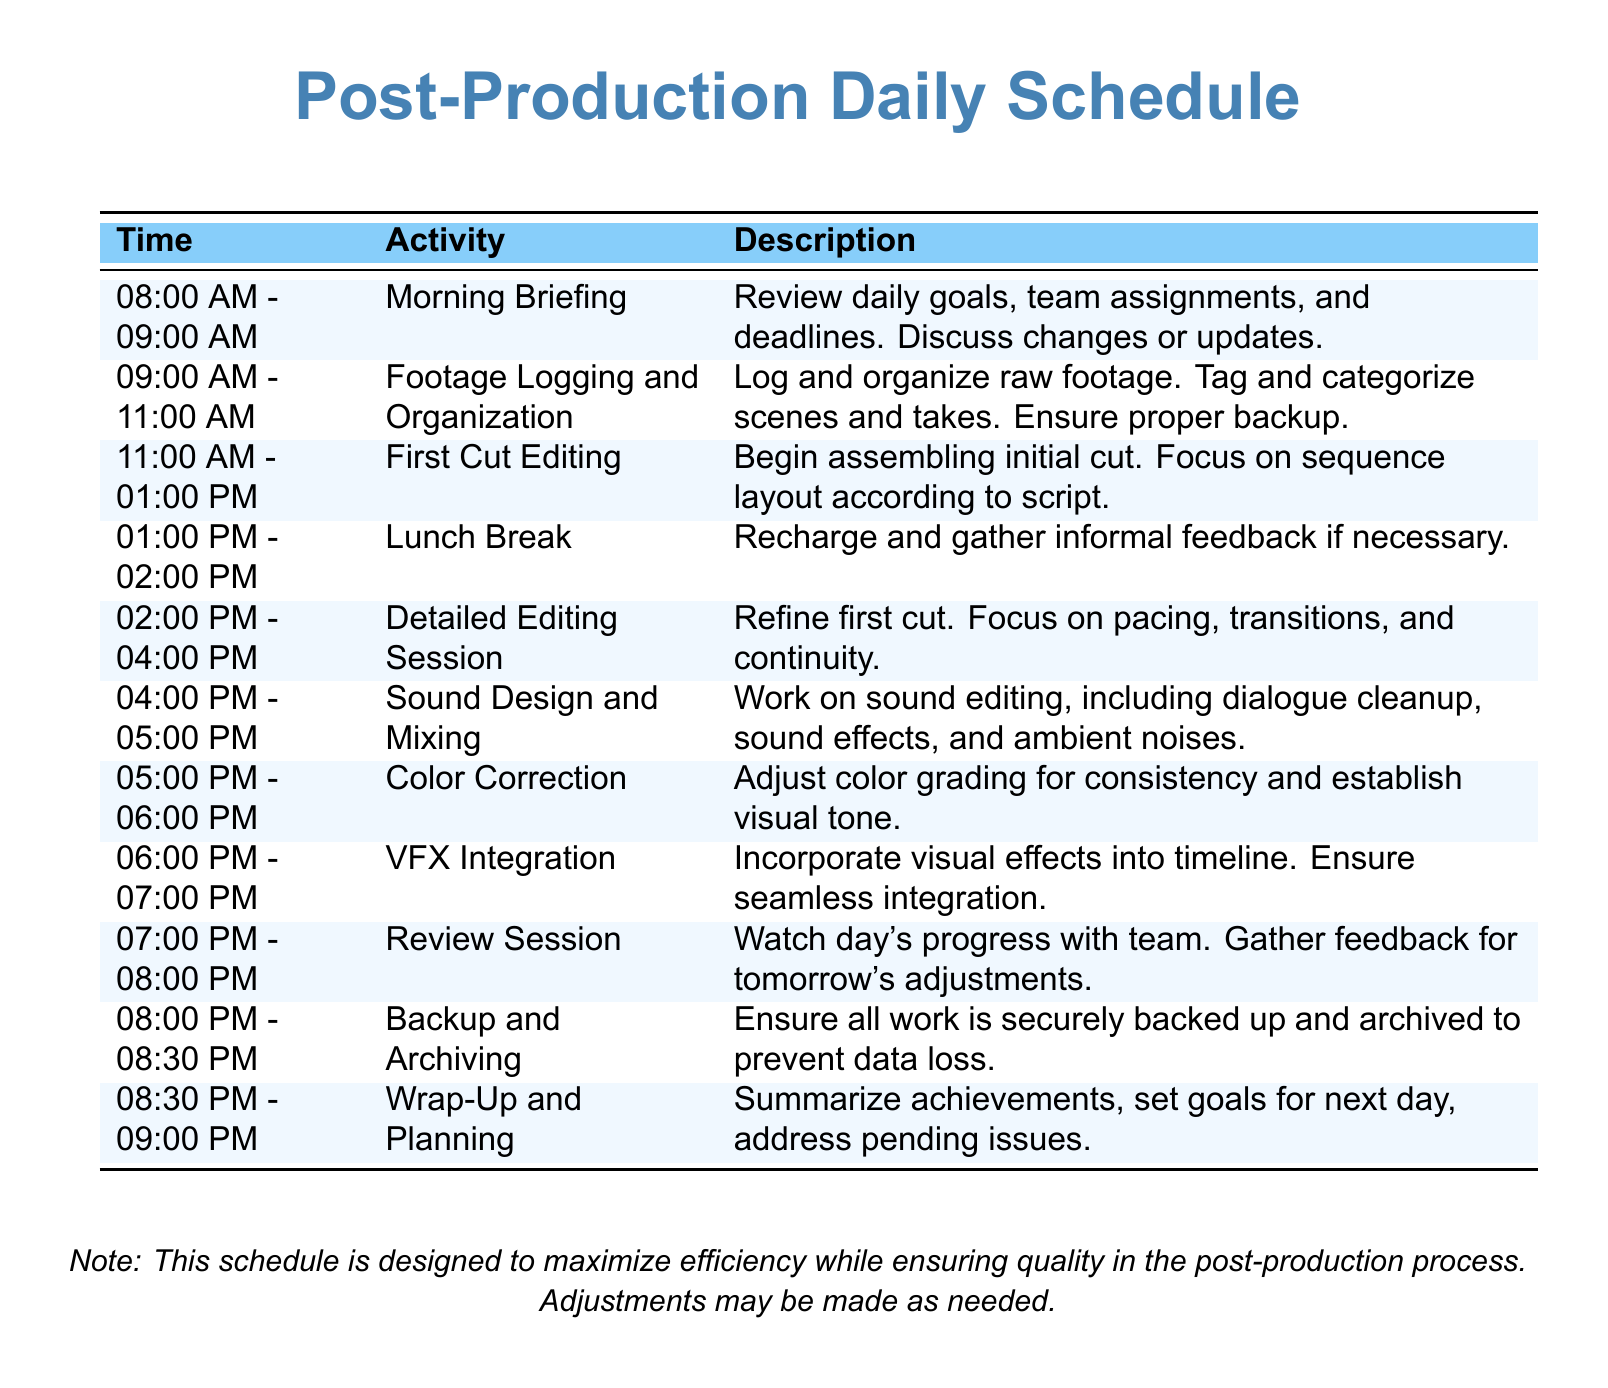What time does the Morning Briefing start? The Morning Briefing begins at 08:00 AM according to the schedule.
Answer: 08:00 AM How long is the lunch break? The schedule indicates that the lunch break lasts for 1 hour from 01:00 PM to 02:00 PM.
Answer: 1 hour What activity takes place after the Detailed Editing Session? The next activity following the Detailed Editing Session is Sound Design and Mixing.
Answer: Sound Design and Mixing How many hours are allocated for First Cut Editing? The First Cut Editing is allocated 2 hours in the schedule from 11:00 AM to 01:00 PM.
Answer: 2 hours What is the purpose of the Review Session? The Review Session is designed to watch the day's progress and gather feedback for adjustments.
Answer: Gather feedback What is the final task before wrapping up the day? The final task before wrapping up is Backup and Archiving.
Answer: Backup and Archiving In what time slot is VFX Integration scheduled? VFX Integration is scheduled from 06:00 PM to 07:00 PM.
Answer: 06:00 PM - 07:00 PM What is the earliest activity listed in the schedule? The earliest activity listed in the schedule is the Morning Briefing.
Answer: Morning Briefing What is stated as a note in the document? The note states that adjustments may be made as needed to maximize efficiency while ensuring quality.
Answer: Adjustments may be made as needed 